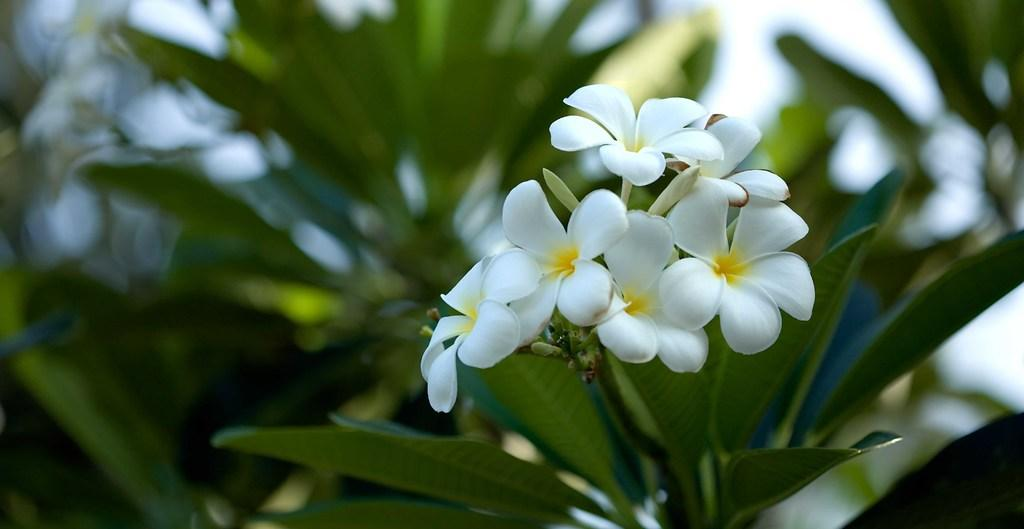What color are the flowers on the plant in the image? The flowers on the plant are white. What stage of growth are some of the flowers in? There are buds on the plant, indicating that some flowers are not yet fully bloomed. How is the image quality at the back of the image? The image is blurry at the back. What can be seen at the top of the image? The sky is visible at the top of the image. What type of disease is affecting the pear in the image? There is no pear present in the image; it features a plant with white flowers. 